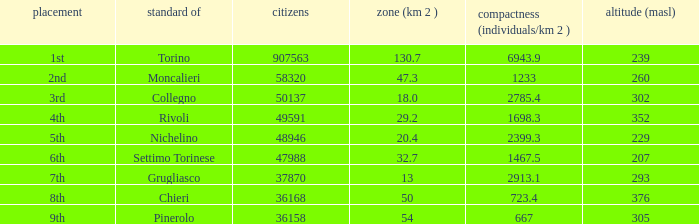What rank is the common with an area of 47.3 km^2? 2nd. 